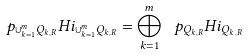<formula> <loc_0><loc_0><loc_500><loc_500>p _ { \cup _ { k = 1 } ^ { m } Q _ { k , R } } H i _ { \cup _ { k = 1 } ^ { m } Q _ { k , R } } = \bigoplus _ { k = 1 } ^ { m } \ p _ { Q _ { k , R } } H i _ { Q _ { k , R } }</formula> 